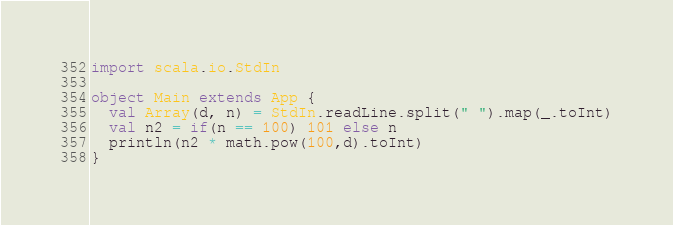Convert code to text. <code><loc_0><loc_0><loc_500><loc_500><_Scala_>import scala.io.StdIn

object Main extends App {
  val Array(d, n) = StdIn.readLine.split(" ").map(_.toInt)
  val n2 = if(n == 100) 101 else n
  println(n2 * math.pow(100,d).toInt)
}
</code> 